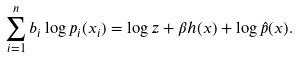<formula> <loc_0><loc_0><loc_500><loc_500>\sum _ { i = 1 } ^ { n } b _ { i } \log p _ { i } ( x _ { i } ) = \log z + \beta h ( x ) + \log \hat { p } ( x ) .</formula> 